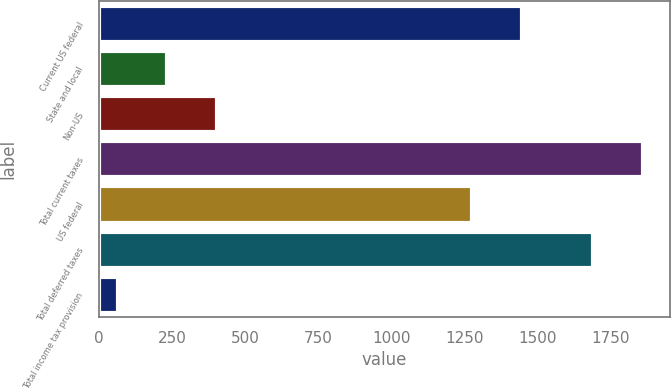<chart> <loc_0><loc_0><loc_500><loc_500><bar_chart><fcel>Current US federal<fcel>State and local<fcel>Non-US<fcel>Total current taxes<fcel>US federal<fcel>Total deferred taxes<fcel>Total income tax provision<nl><fcel>1445<fcel>234<fcel>403<fcel>1859<fcel>1276<fcel>1690<fcel>65<nl></chart> 